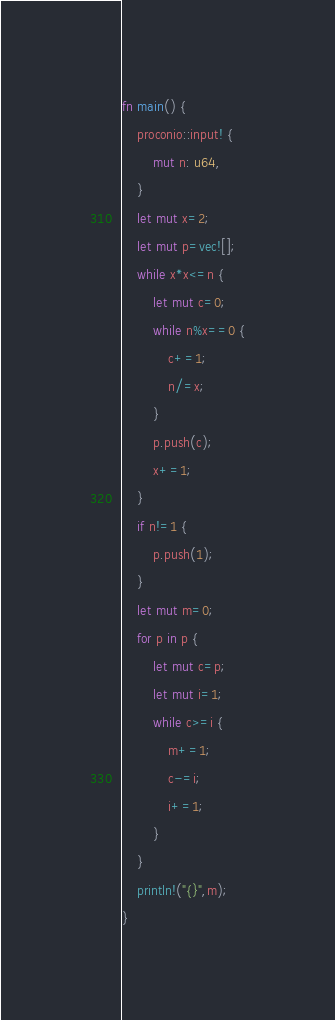<code> <loc_0><loc_0><loc_500><loc_500><_Rust_>fn main() {
    proconio::input! {
        mut n: u64,
    }
    let mut x=2;
    let mut p=vec![];
    while x*x<=n {
        let mut c=0;
        while n%x==0 {
            c+=1;
            n/=x;
        }
        p.push(c);
        x+=1;
    }
    if n!=1 {
        p.push(1);
    }
    let mut m=0;
    for p in p {
        let mut c=p;
        let mut i=1;
        while c>=i {
            m+=1;
            c-=i;
            i+=1;
        }
    }
    println!("{}",m);
}</code> 